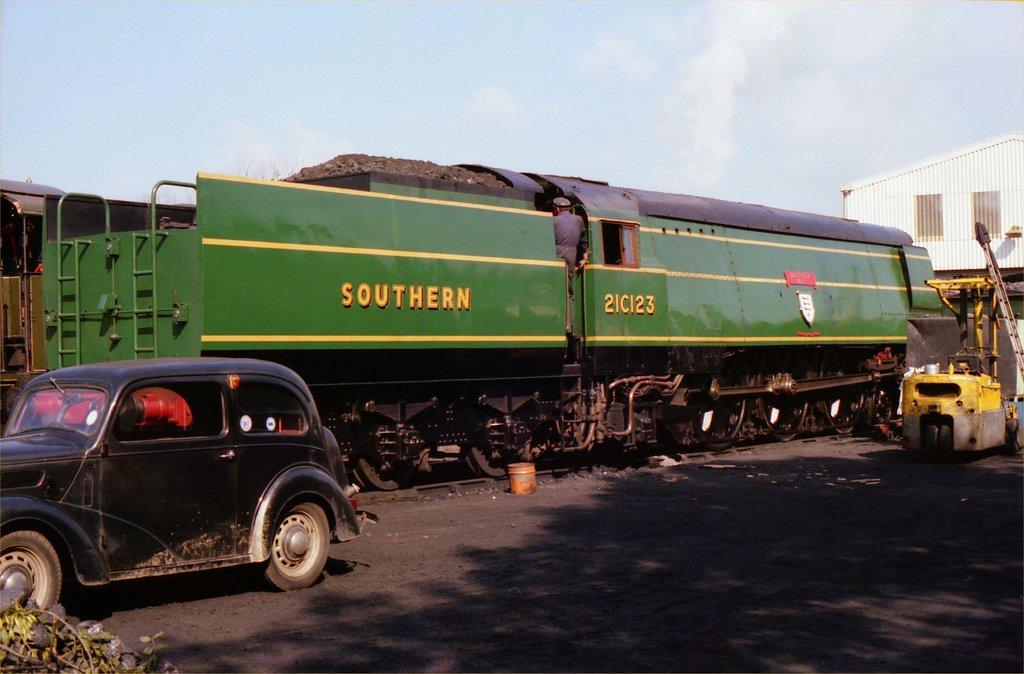What is the main subject of the image? The main subject of the image is a train. Can you describe the train's position in the image? The train is on a track. What is in front of the train? There is a car in front of the train. What can be seen in the background of the image? There is a shed in the background of the image. What is visible above the train and the car? The sky is visible in the image. What type of pen is being used to write on the train in the image? There is no pen or writing present on the train in the image. 